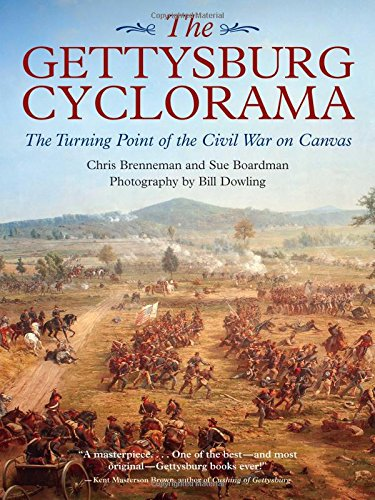Is this a historical book? Yes, this book is historical, as it focuses on the events of the Battle of Gettysburg, providing insights into its strategic, cultural, and military significance during the American Civil War. 